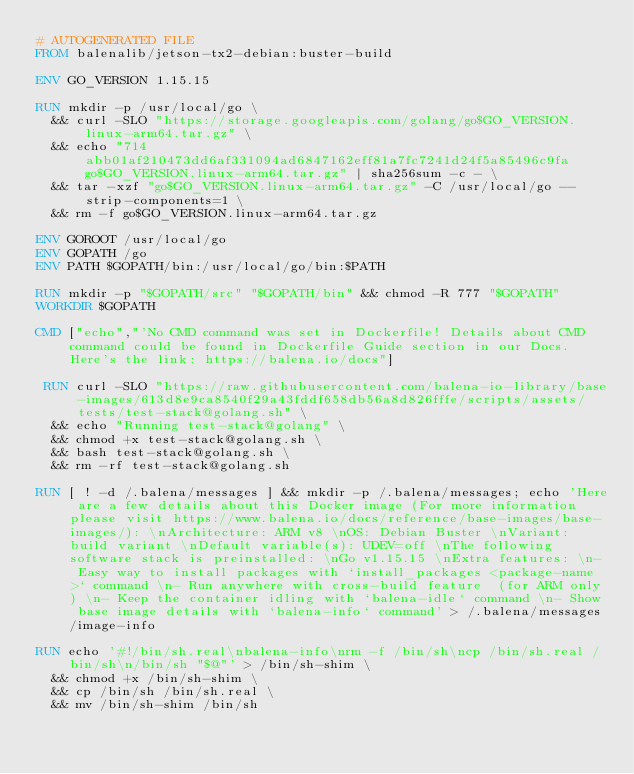<code> <loc_0><loc_0><loc_500><loc_500><_Dockerfile_># AUTOGENERATED FILE
FROM balenalib/jetson-tx2-debian:buster-build

ENV GO_VERSION 1.15.15

RUN mkdir -p /usr/local/go \
	&& curl -SLO "https://storage.googleapis.com/golang/go$GO_VERSION.linux-arm64.tar.gz" \
	&& echo "714abb01af210473dd6af331094ad6847162eff81a7fc7241d24f5a85496c9fa  go$GO_VERSION.linux-arm64.tar.gz" | sha256sum -c - \
	&& tar -xzf "go$GO_VERSION.linux-arm64.tar.gz" -C /usr/local/go --strip-components=1 \
	&& rm -f go$GO_VERSION.linux-arm64.tar.gz

ENV GOROOT /usr/local/go
ENV GOPATH /go
ENV PATH $GOPATH/bin:/usr/local/go/bin:$PATH

RUN mkdir -p "$GOPATH/src" "$GOPATH/bin" && chmod -R 777 "$GOPATH"
WORKDIR $GOPATH

CMD ["echo","'No CMD command was set in Dockerfile! Details about CMD command could be found in Dockerfile Guide section in our Docs. Here's the link: https://balena.io/docs"]

 RUN curl -SLO "https://raw.githubusercontent.com/balena-io-library/base-images/613d8e9ca8540f29a43fddf658db56a8d826fffe/scripts/assets/tests/test-stack@golang.sh" \
  && echo "Running test-stack@golang" \
  && chmod +x test-stack@golang.sh \
  && bash test-stack@golang.sh \
  && rm -rf test-stack@golang.sh 

RUN [ ! -d /.balena/messages ] && mkdir -p /.balena/messages; echo 'Here are a few details about this Docker image (For more information please visit https://www.balena.io/docs/reference/base-images/base-images/): \nArchitecture: ARM v8 \nOS: Debian Buster \nVariant: build variant \nDefault variable(s): UDEV=off \nThe following software stack is preinstalled: \nGo v1.15.15 \nExtra features: \n- Easy way to install packages with `install_packages <package-name>` command \n- Run anywhere with cross-build feature  (for ARM only) \n- Keep the container idling with `balena-idle` command \n- Show base image details with `balena-info` command' > /.balena/messages/image-info

RUN echo '#!/bin/sh.real\nbalena-info\nrm -f /bin/sh\ncp /bin/sh.real /bin/sh\n/bin/sh "$@"' > /bin/sh-shim \
	&& chmod +x /bin/sh-shim \
	&& cp /bin/sh /bin/sh.real \
	&& mv /bin/sh-shim /bin/sh</code> 